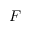Convert formula to latex. <formula><loc_0><loc_0><loc_500><loc_500>F</formula> 